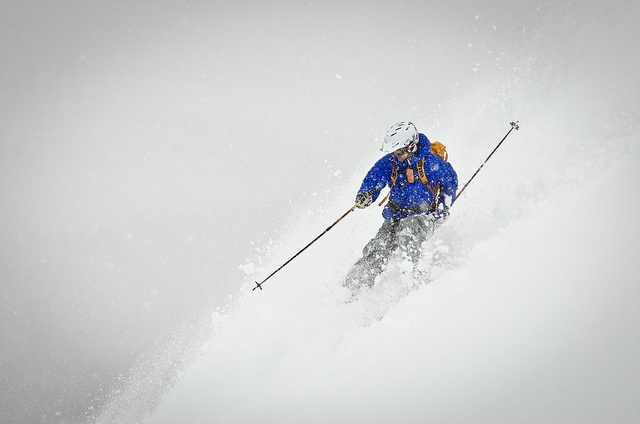Describe the objects in this image and their specific colors. I can see people in darkgray, lightgray, darkblue, and gray tones and backpack in darkgray, olive, orange, black, and gray tones in this image. 